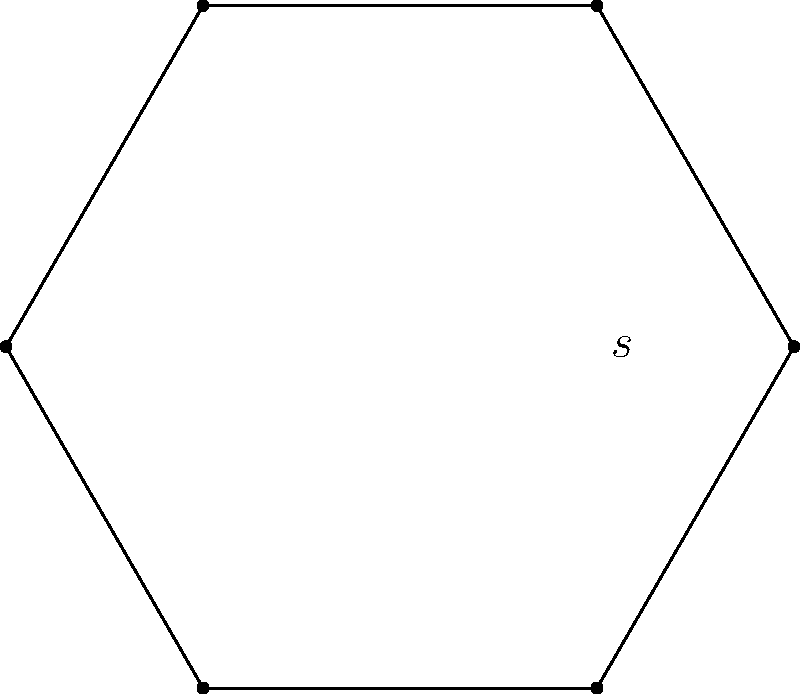In your latest e-sports tournament, the gaming arena is shaped like a regular hexagon. If each side of the hexagon measures $s = 5$ meters, what is the perimeter of the arena? To find the perimeter of a regular hexagon, we need to follow these steps:

1) Recall that a regular hexagon has 6 equal sides.

2) The formula for the perimeter of a regular hexagon is:

   $$P = 6s$$

   where $P$ is the perimeter and $s$ is the length of one side.

3) We are given that $s = 5$ meters.

4) Substituting this value into our formula:

   $$P = 6 \times 5$$

5) Calculating:

   $$P = 30$$

Therefore, the perimeter of the hexagonal gaming arena is 30 meters.
Answer: $30$ meters 